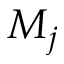<formula> <loc_0><loc_0><loc_500><loc_500>M _ { j }</formula> 